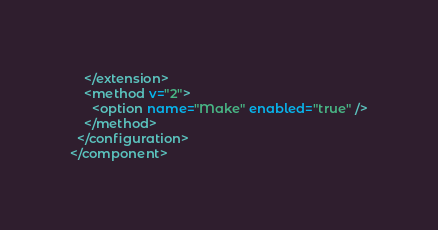<code> <loc_0><loc_0><loc_500><loc_500><_XML_>    </extension>
    <method v="2">
      <option name="Make" enabled="true" />
    </method>
  </configuration>
</component></code> 